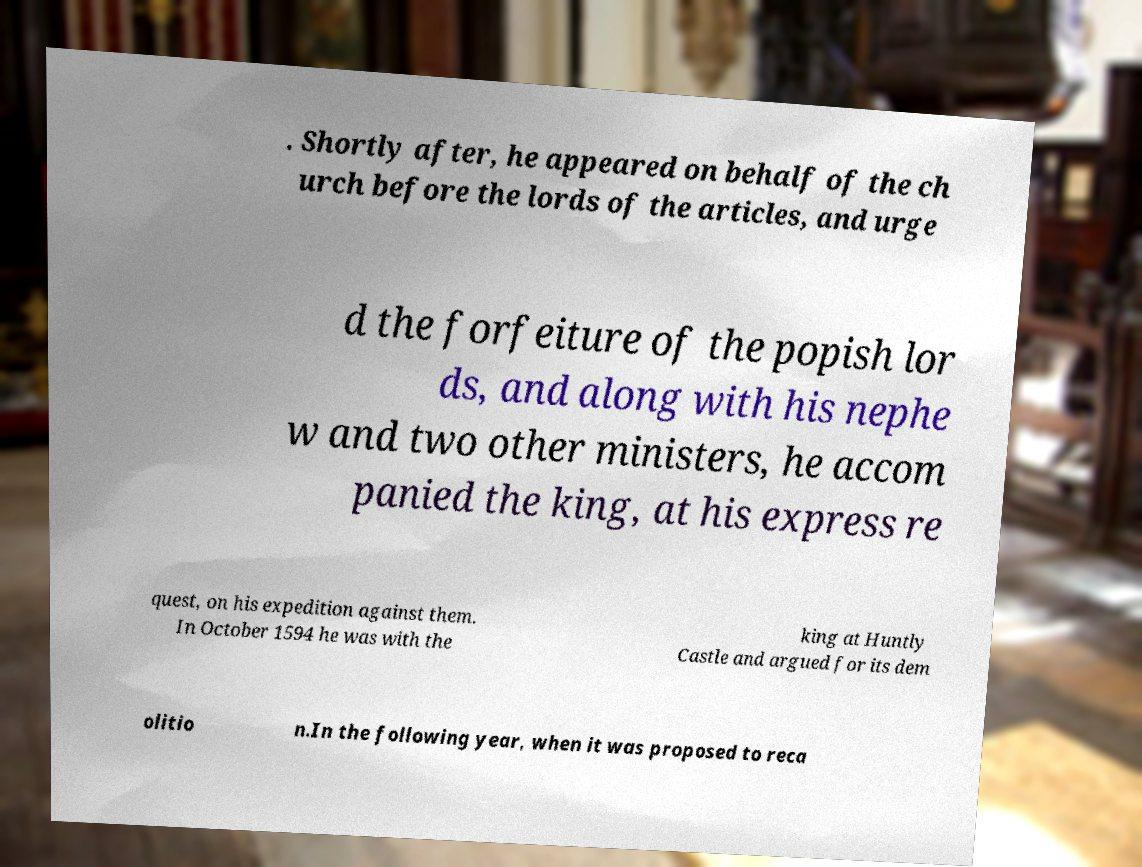I need the written content from this picture converted into text. Can you do that? . Shortly after, he appeared on behalf of the ch urch before the lords of the articles, and urge d the forfeiture of the popish lor ds, and along with his nephe w and two other ministers, he accom panied the king, at his express re quest, on his expedition against them. In October 1594 he was with the king at Huntly Castle and argued for its dem olitio n.In the following year, when it was proposed to reca 